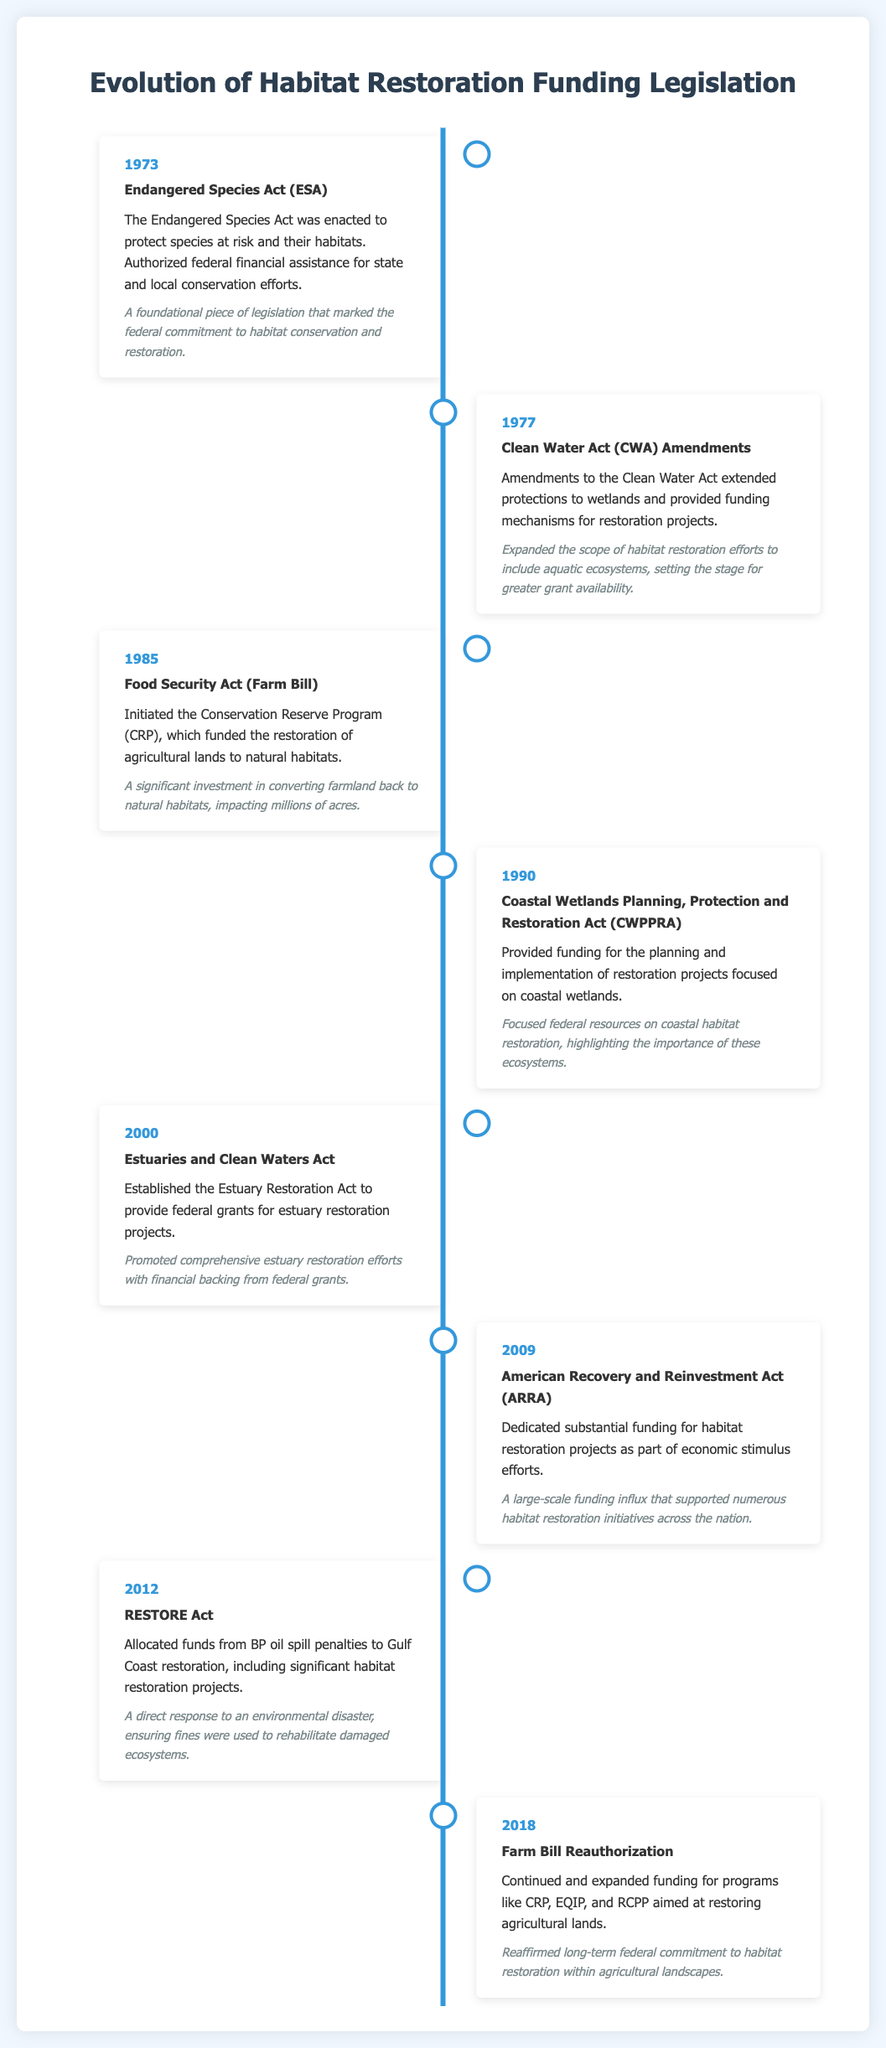What year was the Endangered Species Act enacted? The Endangered Species Act was enacted in 1973, which is noted in the timeline.
Answer: 1973 What legislation initiated the Conservation Reserve Program? The Food Security Act (Farm Bill) initiated the Conservation Reserve Program as indicated in the timeline entry.
Answer: Food Security Act (Farm Bill) What significant act was implemented in 2000? The timeline specifies that the Estuaries and Clean Waters Act was established in 2000.
Answer: Estuaries and Clean Waters Act How much funding was dedicated to habitat restoration in 2009? The American Recovery and Reinvestment Act dedicated substantial funding for habitat restoration projects, although the exact amount is not specified.
Answer: Substantial funding Which act allocated funds from BP oil spill penalties? The RESTORE Act, as highlighted in the 2012 entry of the timeline, allocated funds from BP oil spill penalties.
Answer: RESTORE Act What event led to the significant expansion of funding programs like CRP in 2018? The Farm Bill Reauthorization contributed to the continued and expanded funding for conservation programs aimed at habitat restoration.
Answer: Farm Bill Reauthorization What focus did the Coastal Wetlands Planning, Protection and Restoration Act have? The CWPPRA focused on the planning and implementation of restoration projects for coastal wetlands.
Answer: Coastal wetlands What year marks a large-scale funding influx for habitat projects? The large-scale funding influx for habitat restoration initiatives occurred in 2009 due to the American Recovery and Reinvestment Act.
Answer: 2009 